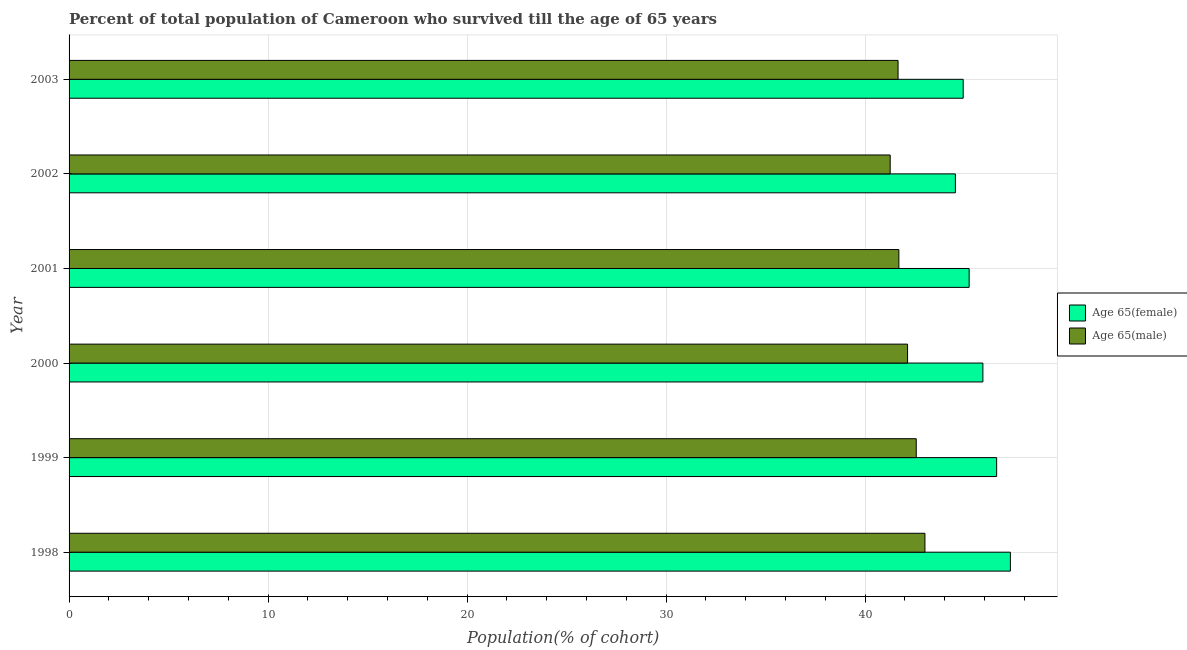How many different coloured bars are there?
Give a very brief answer. 2. How many groups of bars are there?
Your answer should be very brief. 6. In how many cases, is the number of bars for a given year not equal to the number of legend labels?
Provide a succinct answer. 0. What is the percentage of male population who survived till age of 65 in 2000?
Offer a very short reply. 42.14. Across all years, what is the maximum percentage of male population who survived till age of 65?
Offer a very short reply. 43.01. Across all years, what is the minimum percentage of female population who survived till age of 65?
Make the answer very short. 44.54. In which year was the percentage of female population who survived till age of 65 maximum?
Make the answer very short. 1998. What is the total percentage of female population who survived till age of 65 in the graph?
Your answer should be compact. 274.55. What is the difference between the percentage of male population who survived till age of 65 in 2000 and that in 2003?
Make the answer very short. 0.48. What is the difference between the percentage of female population who survived till age of 65 in 2002 and the percentage of male population who survived till age of 65 in 2003?
Offer a terse response. 2.88. What is the average percentage of male population who survived till age of 65 per year?
Ensure brevity in your answer.  42.06. In the year 2003, what is the difference between the percentage of female population who survived till age of 65 and percentage of male population who survived till age of 65?
Offer a very short reply. 3.27. In how many years, is the percentage of male population who survived till age of 65 greater than 34 %?
Ensure brevity in your answer.  6. Is the percentage of female population who survived till age of 65 in 1998 less than that in 1999?
Your response must be concise. No. Is the difference between the percentage of male population who survived till age of 65 in 2001 and 2002 greater than the difference between the percentage of female population who survived till age of 65 in 2001 and 2002?
Offer a terse response. No. What is the difference between the highest and the second highest percentage of female population who survived till age of 65?
Provide a short and direct response. 0.69. Is the sum of the percentage of female population who survived till age of 65 in 2001 and 2002 greater than the maximum percentage of male population who survived till age of 65 across all years?
Offer a terse response. Yes. What does the 1st bar from the top in 1998 represents?
Make the answer very short. Age 65(male). What does the 1st bar from the bottom in 2002 represents?
Your response must be concise. Age 65(female). How many bars are there?
Offer a terse response. 12. What is the difference between two consecutive major ticks on the X-axis?
Offer a very short reply. 10. Are the values on the major ticks of X-axis written in scientific E-notation?
Provide a succinct answer. No. Where does the legend appear in the graph?
Your response must be concise. Center right. How are the legend labels stacked?
Your answer should be compact. Vertical. What is the title of the graph?
Offer a terse response. Percent of total population of Cameroon who survived till the age of 65 years. What is the label or title of the X-axis?
Provide a short and direct response. Population(% of cohort). What is the label or title of the Y-axis?
Make the answer very short. Year. What is the Population(% of cohort) in Age 65(female) in 1998?
Provide a short and direct response. 47.31. What is the Population(% of cohort) in Age 65(male) in 1998?
Make the answer very short. 43.01. What is the Population(% of cohort) of Age 65(female) in 1999?
Ensure brevity in your answer.  46.61. What is the Population(% of cohort) in Age 65(male) in 1999?
Keep it short and to the point. 42.57. What is the Population(% of cohort) in Age 65(female) in 2000?
Make the answer very short. 45.92. What is the Population(% of cohort) of Age 65(male) in 2000?
Offer a terse response. 42.14. What is the Population(% of cohort) in Age 65(female) in 2001?
Keep it short and to the point. 45.23. What is the Population(% of cohort) in Age 65(male) in 2001?
Your answer should be compact. 41.7. What is the Population(% of cohort) in Age 65(female) in 2002?
Give a very brief answer. 44.54. What is the Population(% of cohort) of Age 65(male) in 2002?
Make the answer very short. 41.26. What is the Population(% of cohort) of Age 65(female) in 2003?
Give a very brief answer. 44.93. What is the Population(% of cohort) in Age 65(male) in 2003?
Your response must be concise. 41.66. Across all years, what is the maximum Population(% of cohort) of Age 65(female)?
Provide a short and direct response. 47.31. Across all years, what is the maximum Population(% of cohort) in Age 65(male)?
Provide a short and direct response. 43.01. Across all years, what is the minimum Population(% of cohort) of Age 65(female)?
Your response must be concise. 44.54. Across all years, what is the minimum Population(% of cohort) in Age 65(male)?
Keep it short and to the point. 41.26. What is the total Population(% of cohort) of Age 65(female) in the graph?
Your answer should be very brief. 274.55. What is the total Population(% of cohort) of Age 65(male) in the graph?
Ensure brevity in your answer.  252.35. What is the difference between the Population(% of cohort) in Age 65(female) in 1998 and that in 1999?
Your answer should be very brief. 0.69. What is the difference between the Population(% of cohort) of Age 65(male) in 1998 and that in 1999?
Your answer should be compact. 0.44. What is the difference between the Population(% of cohort) in Age 65(female) in 1998 and that in 2000?
Offer a terse response. 1.38. What is the difference between the Population(% of cohort) of Age 65(male) in 1998 and that in 2000?
Your response must be concise. 0.87. What is the difference between the Population(% of cohort) of Age 65(female) in 1998 and that in 2001?
Your answer should be very brief. 2.07. What is the difference between the Population(% of cohort) of Age 65(male) in 1998 and that in 2001?
Offer a terse response. 1.31. What is the difference between the Population(% of cohort) of Age 65(female) in 1998 and that in 2002?
Give a very brief answer. 2.76. What is the difference between the Population(% of cohort) in Age 65(male) in 1998 and that in 2002?
Give a very brief answer. 1.75. What is the difference between the Population(% of cohort) in Age 65(female) in 1998 and that in 2003?
Offer a very short reply. 2.37. What is the difference between the Population(% of cohort) in Age 65(male) in 1998 and that in 2003?
Provide a short and direct response. 1.35. What is the difference between the Population(% of cohort) of Age 65(female) in 1999 and that in 2000?
Provide a short and direct response. 0.69. What is the difference between the Population(% of cohort) in Age 65(male) in 1999 and that in 2000?
Provide a short and direct response. 0.44. What is the difference between the Population(% of cohort) in Age 65(female) in 1999 and that in 2001?
Provide a succinct answer. 1.38. What is the difference between the Population(% of cohort) in Age 65(male) in 1999 and that in 2001?
Keep it short and to the point. 0.87. What is the difference between the Population(% of cohort) in Age 65(female) in 1999 and that in 2002?
Provide a short and direct response. 2.07. What is the difference between the Population(% of cohort) of Age 65(male) in 1999 and that in 2002?
Provide a succinct answer. 1.31. What is the difference between the Population(% of cohort) in Age 65(female) in 1999 and that in 2003?
Give a very brief answer. 1.68. What is the difference between the Population(% of cohort) in Age 65(male) in 1999 and that in 2003?
Make the answer very short. 0.91. What is the difference between the Population(% of cohort) in Age 65(female) in 2000 and that in 2001?
Your answer should be very brief. 0.69. What is the difference between the Population(% of cohort) of Age 65(male) in 2000 and that in 2001?
Make the answer very short. 0.44. What is the difference between the Population(% of cohort) of Age 65(female) in 2000 and that in 2002?
Keep it short and to the point. 1.38. What is the difference between the Population(% of cohort) of Age 65(male) in 2000 and that in 2002?
Provide a succinct answer. 0.87. What is the difference between the Population(% of cohort) in Age 65(female) in 2000 and that in 2003?
Offer a terse response. 0.99. What is the difference between the Population(% of cohort) of Age 65(male) in 2000 and that in 2003?
Provide a succinct answer. 0.48. What is the difference between the Population(% of cohort) of Age 65(female) in 2001 and that in 2002?
Make the answer very short. 0.69. What is the difference between the Population(% of cohort) in Age 65(male) in 2001 and that in 2002?
Provide a short and direct response. 0.44. What is the difference between the Population(% of cohort) in Age 65(female) in 2001 and that in 2003?
Offer a very short reply. 0.3. What is the difference between the Population(% of cohort) of Age 65(male) in 2001 and that in 2003?
Your response must be concise. 0.04. What is the difference between the Population(% of cohort) of Age 65(female) in 2002 and that in 2003?
Provide a short and direct response. -0.39. What is the difference between the Population(% of cohort) of Age 65(male) in 2002 and that in 2003?
Your answer should be very brief. -0.4. What is the difference between the Population(% of cohort) of Age 65(female) in 1998 and the Population(% of cohort) of Age 65(male) in 1999?
Your answer should be very brief. 4.73. What is the difference between the Population(% of cohort) in Age 65(female) in 1998 and the Population(% of cohort) in Age 65(male) in 2000?
Provide a short and direct response. 5.17. What is the difference between the Population(% of cohort) in Age 65(female) in 1998 and the Population(% of cohort) in Age 65(male) in 2001?
Offer a terse response. 5.6. What is the difference between the Population(% of cohort) in Age 65(female) in 1998 and the Population(% of cohort) in Age 65(male) in 2002?
Provide a succinct answer. 6.04. What is the difference between the Population(% of cohort) in Age 65(female) in 1998 and the Population(% of cohort) in Age 65(male) in 2003?
Offer a very short reply. 5.65. What is the difference between the Population(% of cohort) in Age 65(female) in 1999 and the Population(% of cohort) in Age 65(male) in 2000?
Ensure brevity in your answer.  4.48. What is the difference between the Population(% of cohort) in Age 65(female) in 1999 and the Population(% of cohort) in Age 65(male) in 2001?
Your answer should be compact. 4.91. What is the difference between the Population(% of cohort) in Age 65(female) in 1999 and the Population(% of cohort) in Age 65(male) in 2002?
Your answer should be very brief. 5.35. What is the difference between the Population(% of cohort) in Age 65(female) in 1999 and the Population(% of cohort) in Age 65(male) in 2003?
Make the answer very short. 4.95. What is the difference between the Population(% of cohort) in Age 65(female) in 2000 and the Population(% of cohort) in Age 65(male) in 2001?
Provide a succinct answer. 4.22. What is the difference between the Population(% of cohort) of Age 65(female) in 2000 and the Population(% of cohort) of Age 65(male) in 2002?
Offer a very short reply. 4.66. What is the difference between the Population(% of cohort) of Age 65(female) in 2000 and the Population(% of cohort) of Age 65(male) in 2003?
Keep it short and to the point. 4.26. What is the difference between the Population(% of cohort) in Age 65(female) in 2001 and the Population(% of cohort) in Age 65(male) in 2002?
Your answer should be very brief. 3.97. What is the difference between the Population(% of cohort) in Age 65(female) in 2001 and the Population(% of cohort) in Age 65(male) in 2003?
Give a very brief answer. 3.57. What is the difference between the Population(% of cohort) in Age 65(female) in 2002 and the Population(% of cohort) in Age 65(male) in 2003?
Your answer should be very brief. 2.88. What is the average Population(% of cohort) of Age 65(female) per year?
Offer a terse response. 45.76. What is the average Population(% of cohort) in Age 65(male) per year?
Provide a short and direct response. 42.06. In the year 1998, what is the difference between the Population(% of cohort) of Age 65(female) and Population(% of cohort) of Age 65(male)?
Your answer should be compact. 4.29. In the year 1999, what is the difference between the Population(% of cohort) in Age 65(female) and Population(% of cohort) in Age 65(male)?
Give a very brief answer. 4.04. In the year 2000, what is the difference between the Population(% of cohort) in Age 65(female) and Population(% of cohort) in Age 65(male)?
Offer a very short reply. 3.79. In the year 2001, what is the difference between the Population(% of cohort) of Age 65(female) and Population(% of cohort) of Age 65(male)?
Provide a short and direct response. 3.53. In the year 2002, what is the difference between the Population(% of cohort) of Age 65(female) and Population(% of cohort) of Age 65(male)?
Ensure brevity in your answer.  3.28. In the year 2003, what is the difference between the Population(% of cohort) in Age 65(female) and Population(% of cohort) in Age 65(male)?
Give a very brief answer. 3.27. What is the ratio of the Population(% of cohort) in Age 65(female) in 1998 to that in 1999?
Provide a succinct answer. 1.01. What is the ratio of the Population(% of cohort) of Age 65(male) in 1998 to that in 1999?
Give a very brief answer. 1.01. What is the ratio of the Population(% of cohort) in Age 65(female) in 1998 to that in 2000?
Your response must be concise. 1.03. What is the ratio of the Population(% of cohort) of Age 65(male) in 1998 to that in 2000?
Keep it short and to the point. 1.02. What is the ratio of the Population(% of cohort) of Age 65(female) in 1998 to that in 2001?
Offer a terse response. 1.05. What is the ratio of the Population(% of cohort) in Age 65(male) in 1998 to that in 2001?
Keep it short and to the point. 1.03. What is the ratio of the Population(% of cohort) in Age 65(female) in 1998 to that in 2002?
Your answer should be compact. 1.06. What is the ratio of the Population(% of cohort) in Age 65(male) in 1998 to that in 2002?
Your answer should be very brief. 1.04. What is the ratio of the Population(% of cohort) in Age 65(female) in 1998 to that in 2003?
Your answer should be compact. 1.05. What is the ratio of the Population(% of cohort) of Age 65(male) in 1998 to that in 2003?
Your response must be concise. 1.03. What is the ratio of the Population(% of cohort) of Age 65(female) in 1999 to that in 2000?
Provide a short and direct response. 1.02. What is the ratio of the Population(% of cohort) in Age 65(male) in 1999 to that in 2000?
Provide a short and direct response. 1.01. What is the ratio of the Population(% of cohort) in Age 65(female) in 1999 to that in 2001?
Your answer should be compact. 1.03. What is the ratio of the Population(% of cohort) in Age 65(male) in 1999 to that in 2001?
Keep it short and to the point. 1.02. What is the ratio of the Population(% of cohort) in Age 65(female) in 1999 to that in 2002?
Ensure brevity in your answer.  1.05. What is the ratio of the Population(% of cohort) of Age 65(male) in 1999 to that in 2002?
Provide a short and direct response. 1.03. What is the ratio of the Population(% of cohort) of Age 65(female) in 1999 to that in 2003?
Your answer should be very brief. 1.04. What is the ratio of the Population(% of cohort) of Age 65(male) in 1999 to that in 2003?
Offer a terse response. 1.02. What is the ratio of the Population(% of cohort) in Age 65(female) in 2000 to that in 2001?
Offer a terse response. 1.02. What is the ratio of the Population(% of cohort) in Age 65(male) in 2000 to that in 2001?
Ensure brevity in your answer.  1.01. What is the ratio of the Population(% of cohort) of Age 65(female) in 2000 to that in 2002?
Your answer should be compact. 1.03. What is the ratio of the Population(% of cohort) in Age 65(male) in 2000 to that in 2002?
Your response must be concise. 1.02. What is the ratio of the Population(% of cohort) in Age 65(male) in 2000 to that in 2003?
Offer a terse response. 1.01. What is the ratio of the Population(% of cohort) of Age 65(female) in 2001 to that in 2002?
Give a very brief answer. 1.02. What is the ratio of the Population(% of cohort) in Age 65(male) in 2001 to that in 2002?
Provide a succinct answer. 1.01. What is the ratio of the Population(% of cohort) in Age 65(female) in 2001 to that in 2003?
Keep it short and to the point. 1.01. What is the ratio of the Population(% of cohort) in Age 65(female) in 2002 to that in 2003?
Provide a short and direct response. 0.99. What is the difference between the highest and the second highest Population(% of cohort) in Age 65(female)?
Offer a terse response. 0.69. What is the difference between the highest and the second highest Population(% of cohort) of Age 65(male)?
Keep it short and to the point. 0.44. What is the difference between the highest and the lowest Population(% of cohort) of Age 65(female)?
Ensure brevity in your answer.  2.76. What is the difference between the highest and the lowest Population(% of cohort) in Age 65(male)?
Offer a terse response. 1.75. 